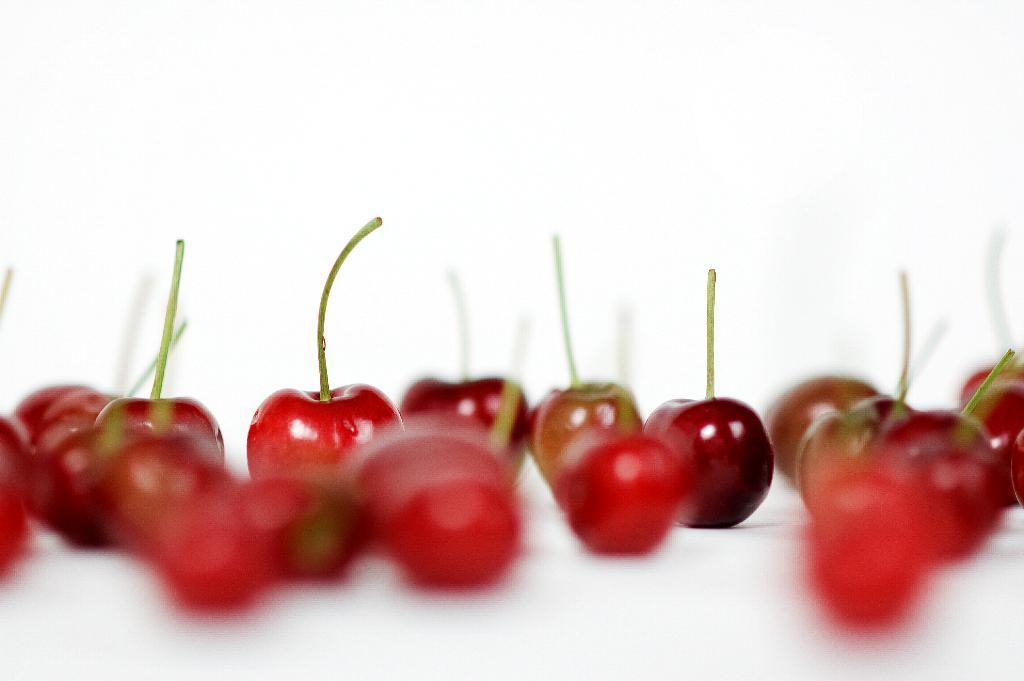What is the main subject in the foreground of the image? There are many cherries in the foreground of the image. What color is the background of the image? The background of the image is white in color. How many faces can be seen in the image? There are no faces present in the image; it features cherries in the foreground and a white background. 